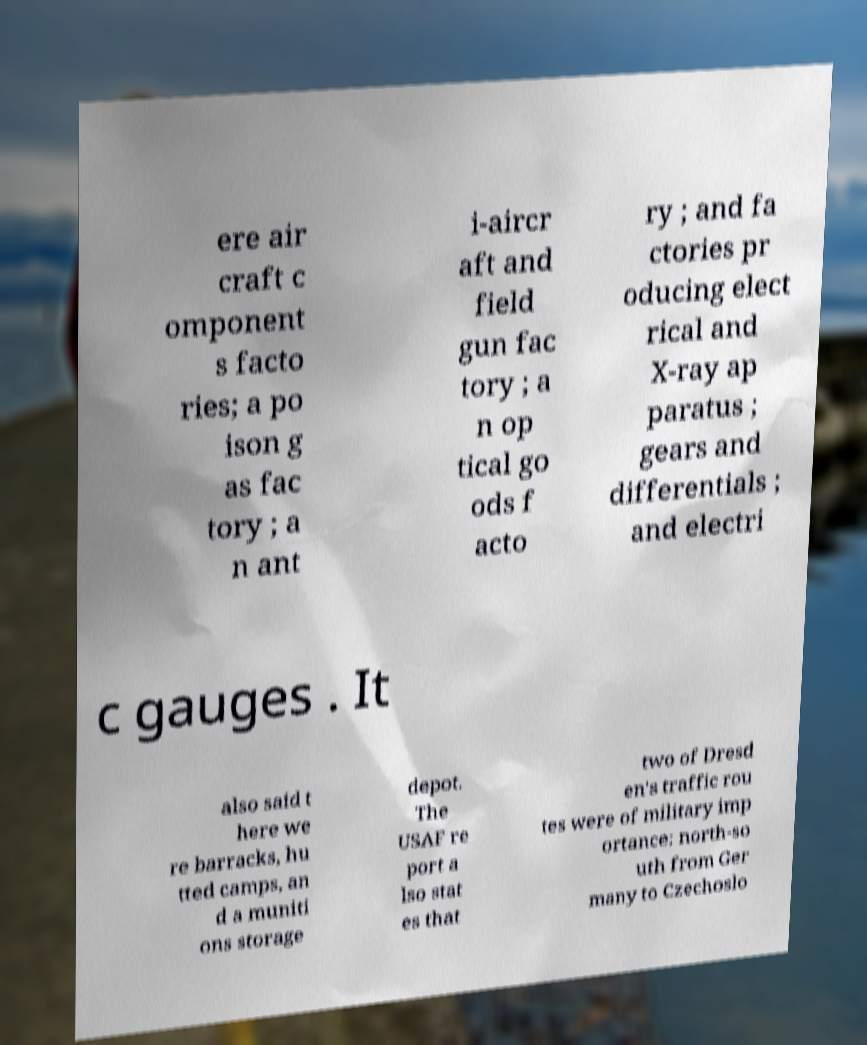Can you read and provide the text displayed in the image?This photo seems to have some interesting text. Can you extract and type it out for me? ere air craft c omponent s facto ries; a po ison g as fac tory ; a n ant i-aircr aft and field gun fac tory ; a n op tical go ods f acto ry ; and fa ctories pr oducing elect rical and X-ray ap paratus ; gears and differentials ; and electri c gauges . It also said t here we re barracks, hu tted camps, an d a muniti ons storage depot. The USAF re port a lso stat es that two of Dresd en's traffic rou tes were of military imp ortance: north-so uth from Ger many to Czechoslo 